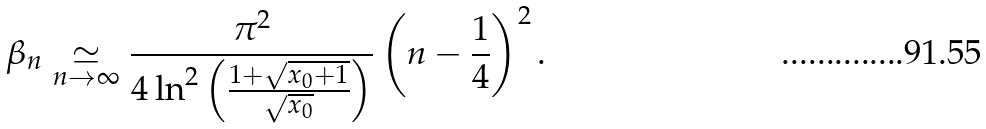<formula> <loc_0><loc_0><loc_500><loc_500>\beta _ { n } \underset { n \rightarrow \infty } { \simeq } \frac { \pi ^ { 2 } } { 4 \ln ^ { 2 } \left ( \frac { 1 + \sqrt { x _ { 0 } + 1 } } { \sqrt { x _ { 0 } } } \right ) } \left ( n - \frac { 1 } { 4 } \right ) ^ { 2 } .</formula> 